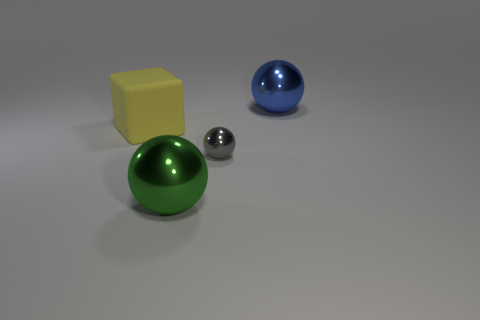There is a large ball that is right of the big metallic sphere that is in front of the tiny gray shiny object; is there a yellow cube on the right side of it? no 